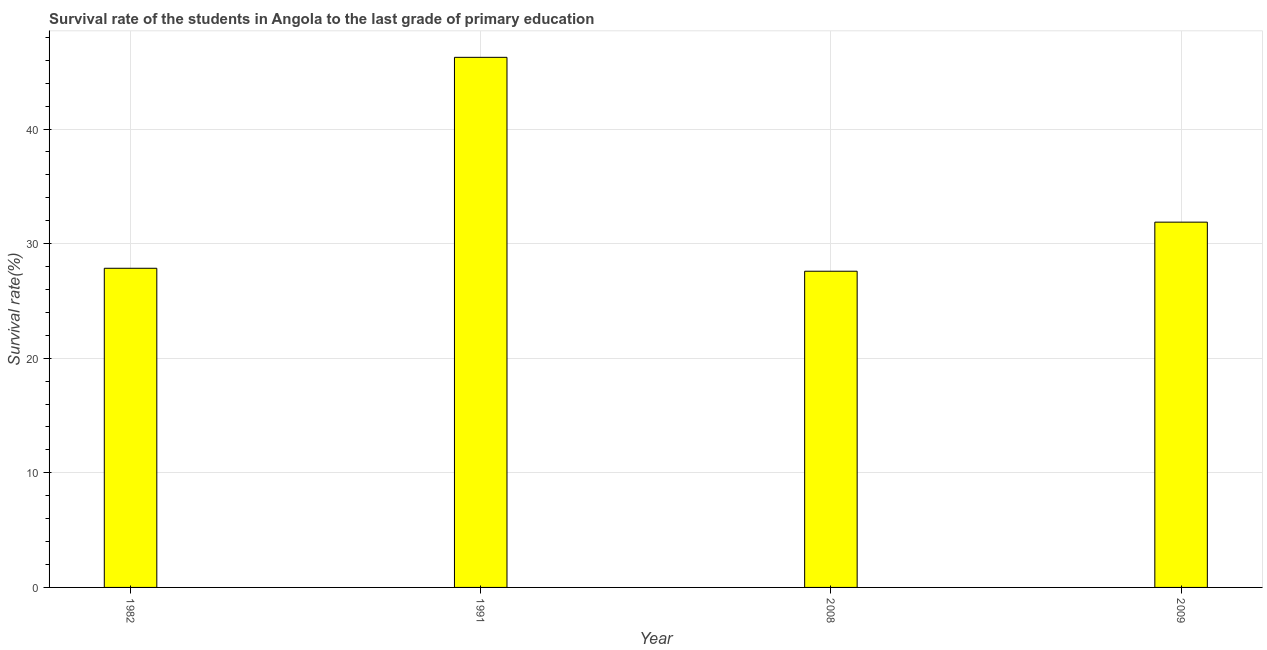What is the title of the graph?
Provide a short and direct response. Survival rate of the students in Angola to the last grade of primary education. What is the label or title of the Y-axis?
Give a very brief answer. Survival rate(%). What is the survival rate in primary education in 1982?
Keep it short and to the point. 27.85. Across all years, what is the maximum survival rate in primary education?
Your answer should be compact. 46.25. Across all years, what is the minimum survival rate in primary education?
Keep it short and to the point. 27.59. In which year was the survival rate in primary education minimum?
Make the answer very short. 2008. What is the sum of the survival rate in primary education?
Make the answer very short. 133.57. What is the difference between the survival rate in primary education in 1991 and 2008?
Keep it short and to the point. 18.66. What is the average survival rate in primary education per year?
Offer a terse response. 33.39. What is the median survival rate in primary education?
Keep it short and to the point. 29.86. In how many years, is the survival rate in primary education greater than 38 %?
Your answer should be very brief. 1. What is the difference between the highest and the second highest survival rate in primary education?
Offer a terse response. 14.38. What is the difference between the highest and the lowest survival rate in primary education?
Ensure brevity in your answer.  18.66. In how many years, is the survival rate in primary education greater than the average survival rate in primary education taken over all years?
Keep it short and to the point. 1. How many bars are there?
Keep it short and to the point. 4. What is the difference between two consecutive major ticks on the Y-axis?
Your answer should be very brief. 10. What is the Survival rate(%) of 1982?
Keep it short and to the point. 27.85. What is the Survival rate(%) of 1991?
Keep it short and to the point. 46.25. What is the Survival rate(%) of 2008?
Give a very brief answer. 27.59. What is the Survival rate(%) of 2009?
Keep it short and to the point. 31.87. What is the difference between the Survival rate(%) in 1982 and 1991?
Provide a short and direct response. -18.41. What is the difference between the Survival rate(%) in 1982 and 2008?
Your answer should be very brief. 0.26. What is the difference between the Survival rate(%) in 1982 and 2009?
Provide a short and direct response. -4.02. What is the difference between the Survival rate(%) in 1991 and 2008?
Your answer should be very brief. 18.66. What is the difference between the Survival rate(%) in 1991 and 2009?
Provide a short and direct response. 14.38. What is the difference between the Survival rate(%) in 2008 and 2009?
Your answer should be compact. -4.28. What is the ratio of the Survival rate(%) in 1982 to that in 1991?
Give a very brief answer. 0.6. What is the ratio of the Survival rate(%) in 1982 to that in 2009?
Your response must be concise. 0.87. What is the ratio of the Survival rate(%) in 1991 to that in 2008?
Provide a short and direct response. 1.68. What is the ratio of the Survival rate(%) in 1991 to that in 2009?
Your response must be concise. 1.45. What is the ratio of the Survival rate(%) in 2008 to that in 2009?
Ensure brevity in your answer.  0.87. 